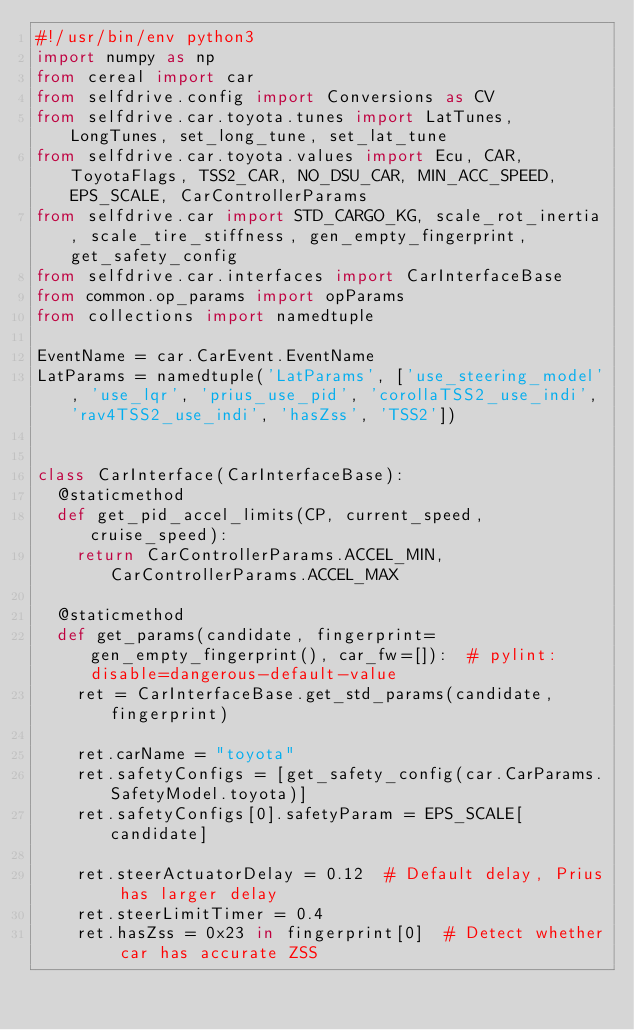<code> <loc_0><loc_0><loc_500><loc_500><_Python_>#!/usr/bin/env python3
import numpy as np
from cereal import car
from selfdrive.config import Conversions as CV
from selfdrive.car.toyota.tunes import LatTunes, LongTunes, set_long_tune, set_lat_tune
from selfdrive.car.toyota.values import Ecu, CAR, ToyotaFlags, TSS2_CAR, NO_DSU_CAR, MIN_ACC_SPEED, EPS_SCALE, CarControllerParams
from selfdrive.car import STD_CARGO_KG, scale_rot_inertia, scale_tire_stiffness, gen_empty_fingerprint, get_safety_config
from selfdrive.car.interfaces import CarInterfaceBase
from common.op_params import opParams
from collections import namedtuple

EventName = car.CarEvent.EventName
LatParams = namedtuple('LatParams', ['use_steering_model', 'use_lqr', 'prius_use_pid', 'corollaTSS2_use_indi', 'rav4TSS2_use_indi', 'hasZss', 'TSS2'])


class CarInterface(CarInterfaceBase):
  @staticmethod
  def get_pid_accel_limits(CP, current_speed, cruise_speed):
    return CarControllerParams.ACCEL_MIN, CarControllerParams.ACCEL_MAX

  @staticmethod
  def get_params(candidate, fingerprint=gen_empty_fingerprint(), car_fw=[]):  # pylint: disable=dangerous-default-value
    ret = CarInterfaceBase.get_std_params(candidate, fingerprint)

    ret.carName = "toyota"
    ret.safetyConfigs = [get_safety_config(car.CarParams.SafetyModel.toyota)]
    ret.safetyConfigs[0].safetyParam = EPS_SCALE[candidate]

    ret.steerActuatorDelay = 0.12  # Default delay, Prius has larger delay
    ret.steerLimitTimer = 0.4
    ret.hasZss = 0x23 in fingerprint[0]  # Detect whether car has accurate ZSS</code> 